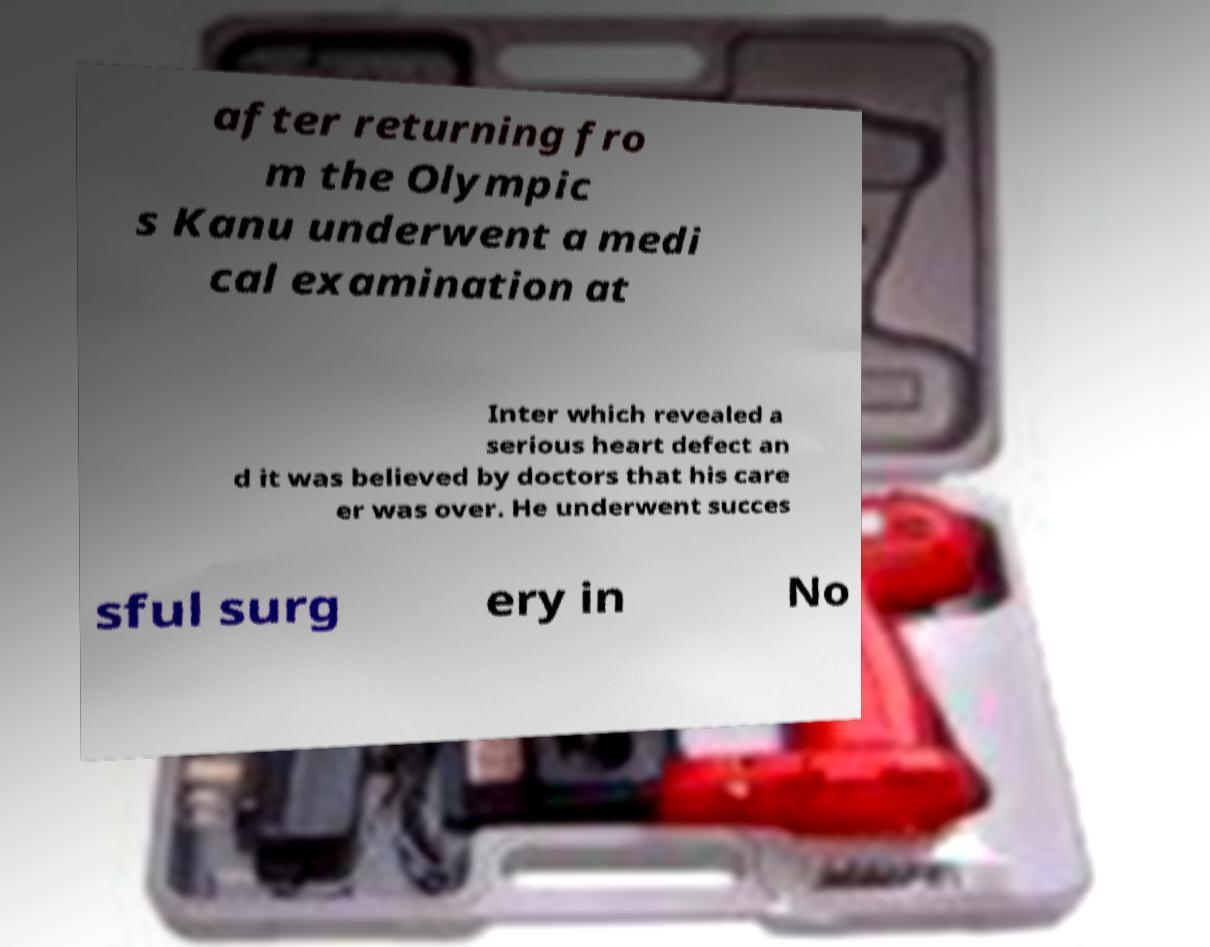What messages or text are displayed in this image? I need them in a readable, typed format. after returning fro m the Olympic s Kanu underwent a medi cal examination at Inter which revealed a serious heart defect an d it was believed by doctors that his care er was over. He underwent succes sful surg ery in No 